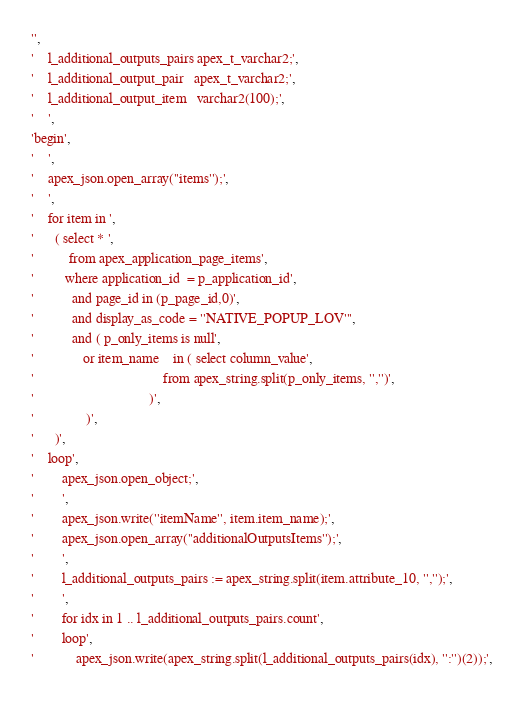<code> <loc_0><loc_0><loc_500><loc_500><_SQL_>'',
'    l_additional_outputs_pairs apex_t_varchar2;',
'    l_additional_output_pair   apex_t_varchar2;',
'    l_additional_output_item   varchar2(100);',
'    ',
'begin',
'    ',
'    apex_json.open_array(''items'');',
'    ',
'    for item in ',
'      ( select * ',
'          from apex_application_page_items',
'         where application_id  = p_application_id',
'           and page_id in (p_page_id,0)',
'           and display_as_code = ''NATIVE_POPUP_LOV''',
'           and ( p_only_items is null',
'              or item_name    in ( select column_value',
'                                     from apex_string.split(p_only_items, '','')',
'                                 )',
'               )',
'      )',
'    loop',
'        apex_json.open_object;',
'        ',
'        apex_json.write(''itemName'', item.item_name);',
'        apex_json.open_array(''additionalOutputsItems'');',
'        ',
'        l_additional_outputs_pairs := apex_string.split(item.attribute_10, '','');',
'        ',
'        for idx in 1 .. l_additional_outputs_pairs.count',
'        loop',
'            apex_json.write(apex_string.split(l_additional_outputs_pairs(idx), '':'')(2));',</code> 